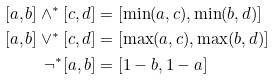Convert formula to latex. <formula><loc_0><loc_0><loc_500><loc_500>[ a , b ] \land ^ { * } [ c , d ] & = [ \min ( a , c ) , \min ( b , d ) ] \\ [ a , b ] \vee ^ { * } [ c , d ] & = [ \max ( a , c ) , \max ( b , d ) ] \\ \neg ^ { * } [ a , b ] & = [ 1 - b , 1 - a ]</formula> 